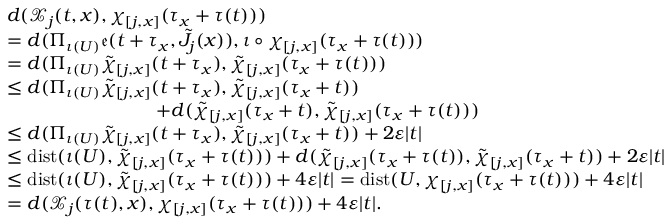<formula> <loc_0><loc_0><loc_500><loc_500>\begin{array} { r l } & { d ( \mathcal { X } _ { j } ( t , x ) , \chi _ { [ j , x ] } ( \tau _ { x } + \tau ( t ) ) ) } \\ & { = d ( \Pi _ { \iota ( U ) } \mathfrak { e } ( t + \tau _ { x } , \tilde { J } _ { j } ( x ) ) , \iota \circ \chi _ { [ j , x ] } ( \tau _ { x } + \tau ( t ) ) ) } \\ & { = d ( \Pi _ { \iota ( U ) } \tilde { \chi } _ { [ j , x ] } ( t + \tau _ { x } ) , \tilde { \chi } _ { [ j , x ] } ( \tau _ { x } + \tau ( t ) ) ) } \\ & { \leq d ( \Pi _ { \iota ( U ) } \tilde { \chi } _ { [ j , x ] } ( t + \tau _ { x } ) , \tilde { \chi } _ { [ j , x ] } ( \tau _ { x } + t ) ) } \\ & { \quad + d ( \tilde { \chi } _ { [ j , x ] } ( \tau _ { x } + t ) , \tilde { \chi } _ { [ j , x ] } ( \tau _ { x } + \tau ( t ) ) ) } \\ & { \leq d ( \Pi _ { \iota ( U ) } \tilde { \chi } _ { [ j , x ] } ( t + \tau _ { x } ) , \tilde { \chi } _ { [ j , x ] } ( \tau _ { x } + t ) ) + 2 \varepsilon | t | } \\ & { \leq d i s t ( \iota ( U ) , \tilde { \chi } _ { [ j , x ] } ( \tau _ { x } + \tau ( t ) ) ) + d ( \tilde { \chi } _ { [ j , x ] } ( \tau _ { x } + \tau ( t ) ) , \tilde { \chi } _ { [ j , x ] } ( \tau _ { x } + t ) ) + 2 \varepsilon | t | } \\ & { \leq d i s t ( \iota ( U ) , \tilde { \chi } _ { [ j , x ] } ( \tau _ { x } + \tau ( t ) ) ) + 4 \varepsilon | t | = d i s t ( U , \chi _ { [ j , x ] } ( \tau _ { x } + \tau ( t ) ) ) + 4 \varepsilon | t | } \\ & { = d ( \mathcal { X } _ { j } ( \tau ( t ) , x ) , \chi _ { [ j , x ] } ( \tau _ { x } + \tau ( t ) ) ) + 4 \varepsilon | t | . } \end{array}</formula> 